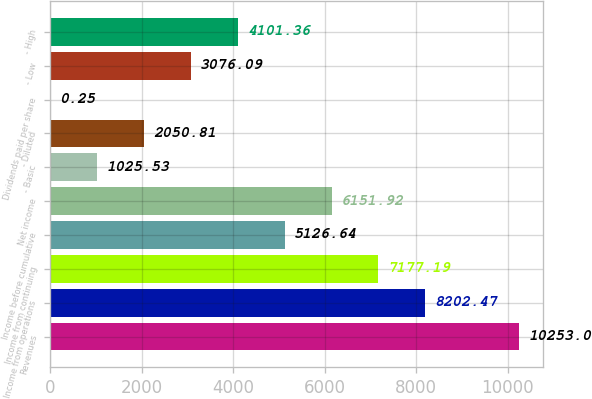Convert chart to OTSL. <chart><loc_0><loc_0><loc_500><loc_500><bar_chart><fcel>Revenues<fcel>Income from operations<fcel>Income from continuing<fcel>Income before cumulative<fcel>Net income<fcel>- Basic<fcel>- Diluted<fcel>Dividends paid per share<fcel>- Low<fcel>- High<nl><fcel>10253<fcel>8202.47<fcel>7177.19<fcel>5126.64<fcel>6151.92<fcel>1025.53<fcel>2050.81<fcel>0.25<fcel>3076.09<fcel>4101.36<nl></chart> 